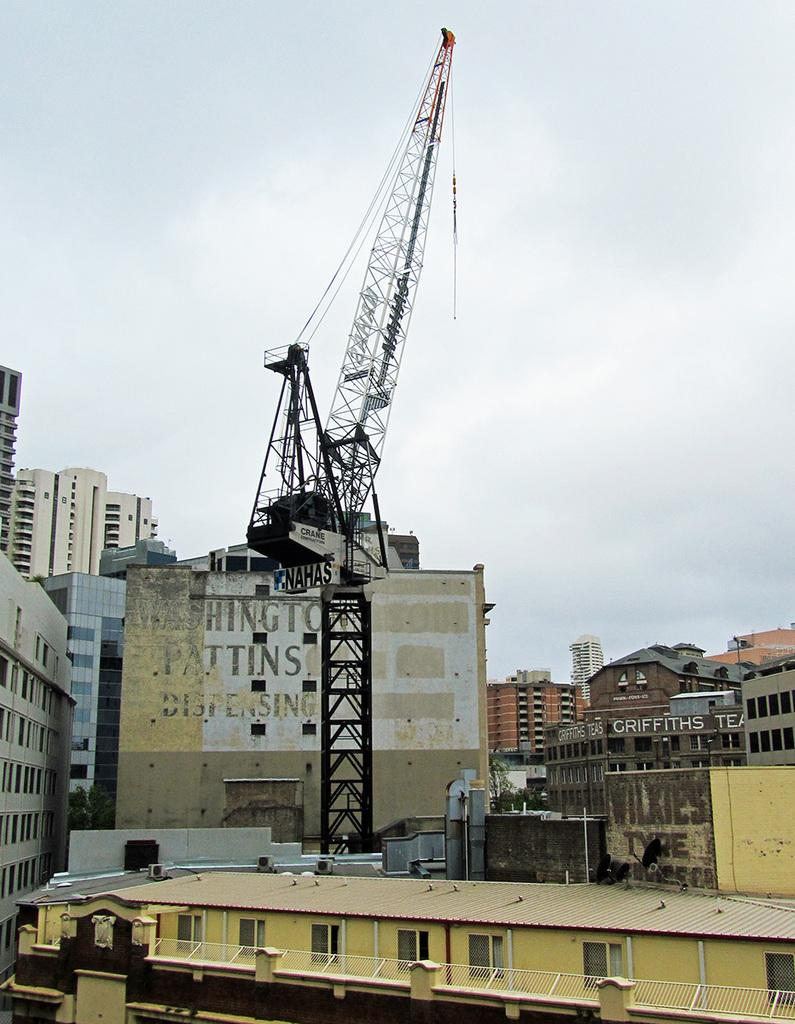What type of structures can be seen in the image? There are buildings in the image. What construction equipment is present in the image? There is a tower crane in the image. What can be seen in the background of the image? The sky is visible in the background of the image. What type of food is the governor eating with the deer in the image? There is no food, governor, or deer present in the image. 